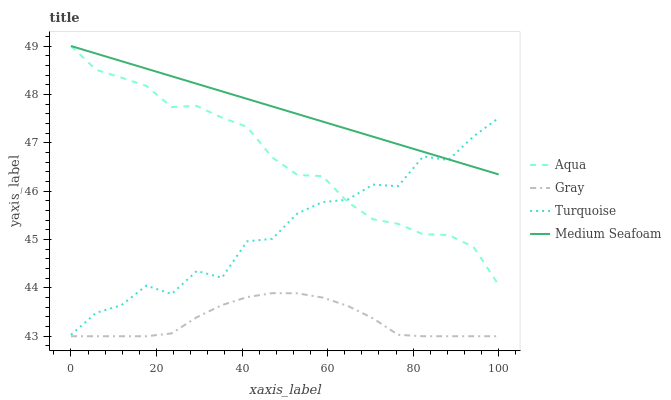Does Gray have the minimum area under the curve?
Answer yes or no. Yes. Does Medium Seafoam have the maximum area under the curve?
Answer yes or no. Yes. Does Turquoise have the minimum area under the curve?
Answer yes or no. No. Does Turquoise have the maximum area under the curve?
Answer yes or no. No. Is Medium Seafoam the smoothest?
Answer yes or no. Yes. Is Turquoise the roughest?
Answer yes or no. Yes. Is Aqua the smoothest?
Answer yes or no. No. Is Aqua the roughest?
Answer yes or no. No. Does Gray have the lowest value?
Answer yes or no. Yes. Does Turquoise have the lowest value?
Answer yes or no. No. Does Medium Seafoam have the highest value?
Answer yes or no. Yes. Does Turquoise have the highest value?
Answer yes or no. No. Is Gray less than Aqua?
Answer yes or no. Yes. Is Aqua greater than Gray?
Answer yes or no. Yes. Does Turquoise intersect Medium Seafoam?
Answer yes or no. Yes. Is Turquoise less than Medium Seafoam?
Answer yes or no. No. Is Turquoise greater than Medium Seafoam?
Answer yes or no. No. Does Gray intersect Aqua?
Answer yes or no. No. 